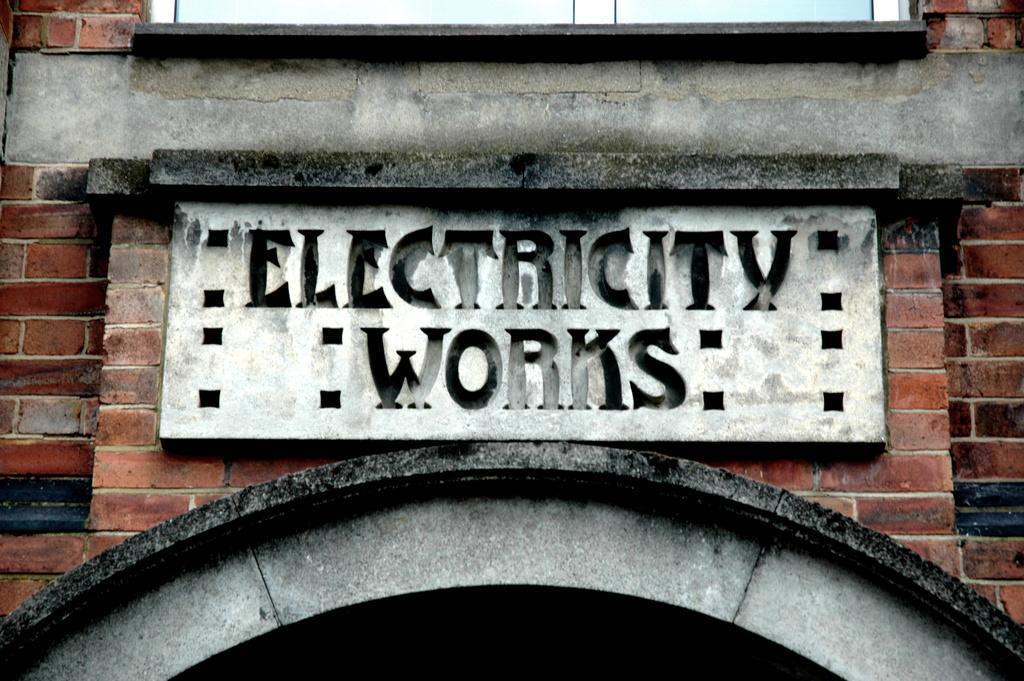What type of structure is visible in the image? There is a building in the image. What is written or displayed on the building? There is a name board on the building. What feature can be seen at the top of the building? There is a glass window at the top of the building. Can you see anyone taking a bath in the image? There is no indication of a bath or anyone taking a bath in the image. 